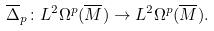<formula> <loc_0><loc_0><loc_500><loc_500>\overline { \Delta } _ { p } \colon L ^ { 2 } \Omega ^ { p } ( \overline { M } ) \to L ^ { 2 } \Omega ^ { p } ( \overline { M } ) .</formula> 